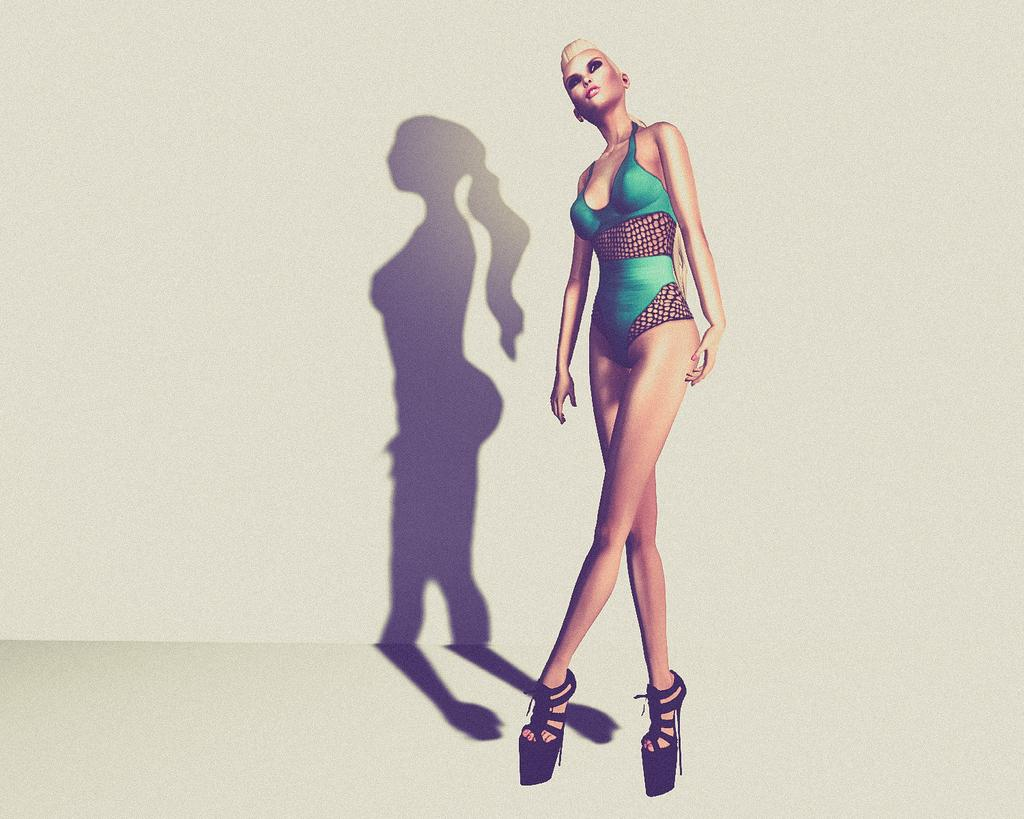What type of image is present in the picture? The image contains an animated image of a woman. What is the woman doing in the image? The woman is standing in the image. What type of footwear is the woman wearing? The woman is wearing high heels in the image. What color is the top that the woman is wearing? The woman is wearing a green top in the image. What type of butter is being used in the arithmetic problem shown in the image? There is no butter or arithmetic problem present in the image; it features an animated woman standing and wearing specific clothing. 